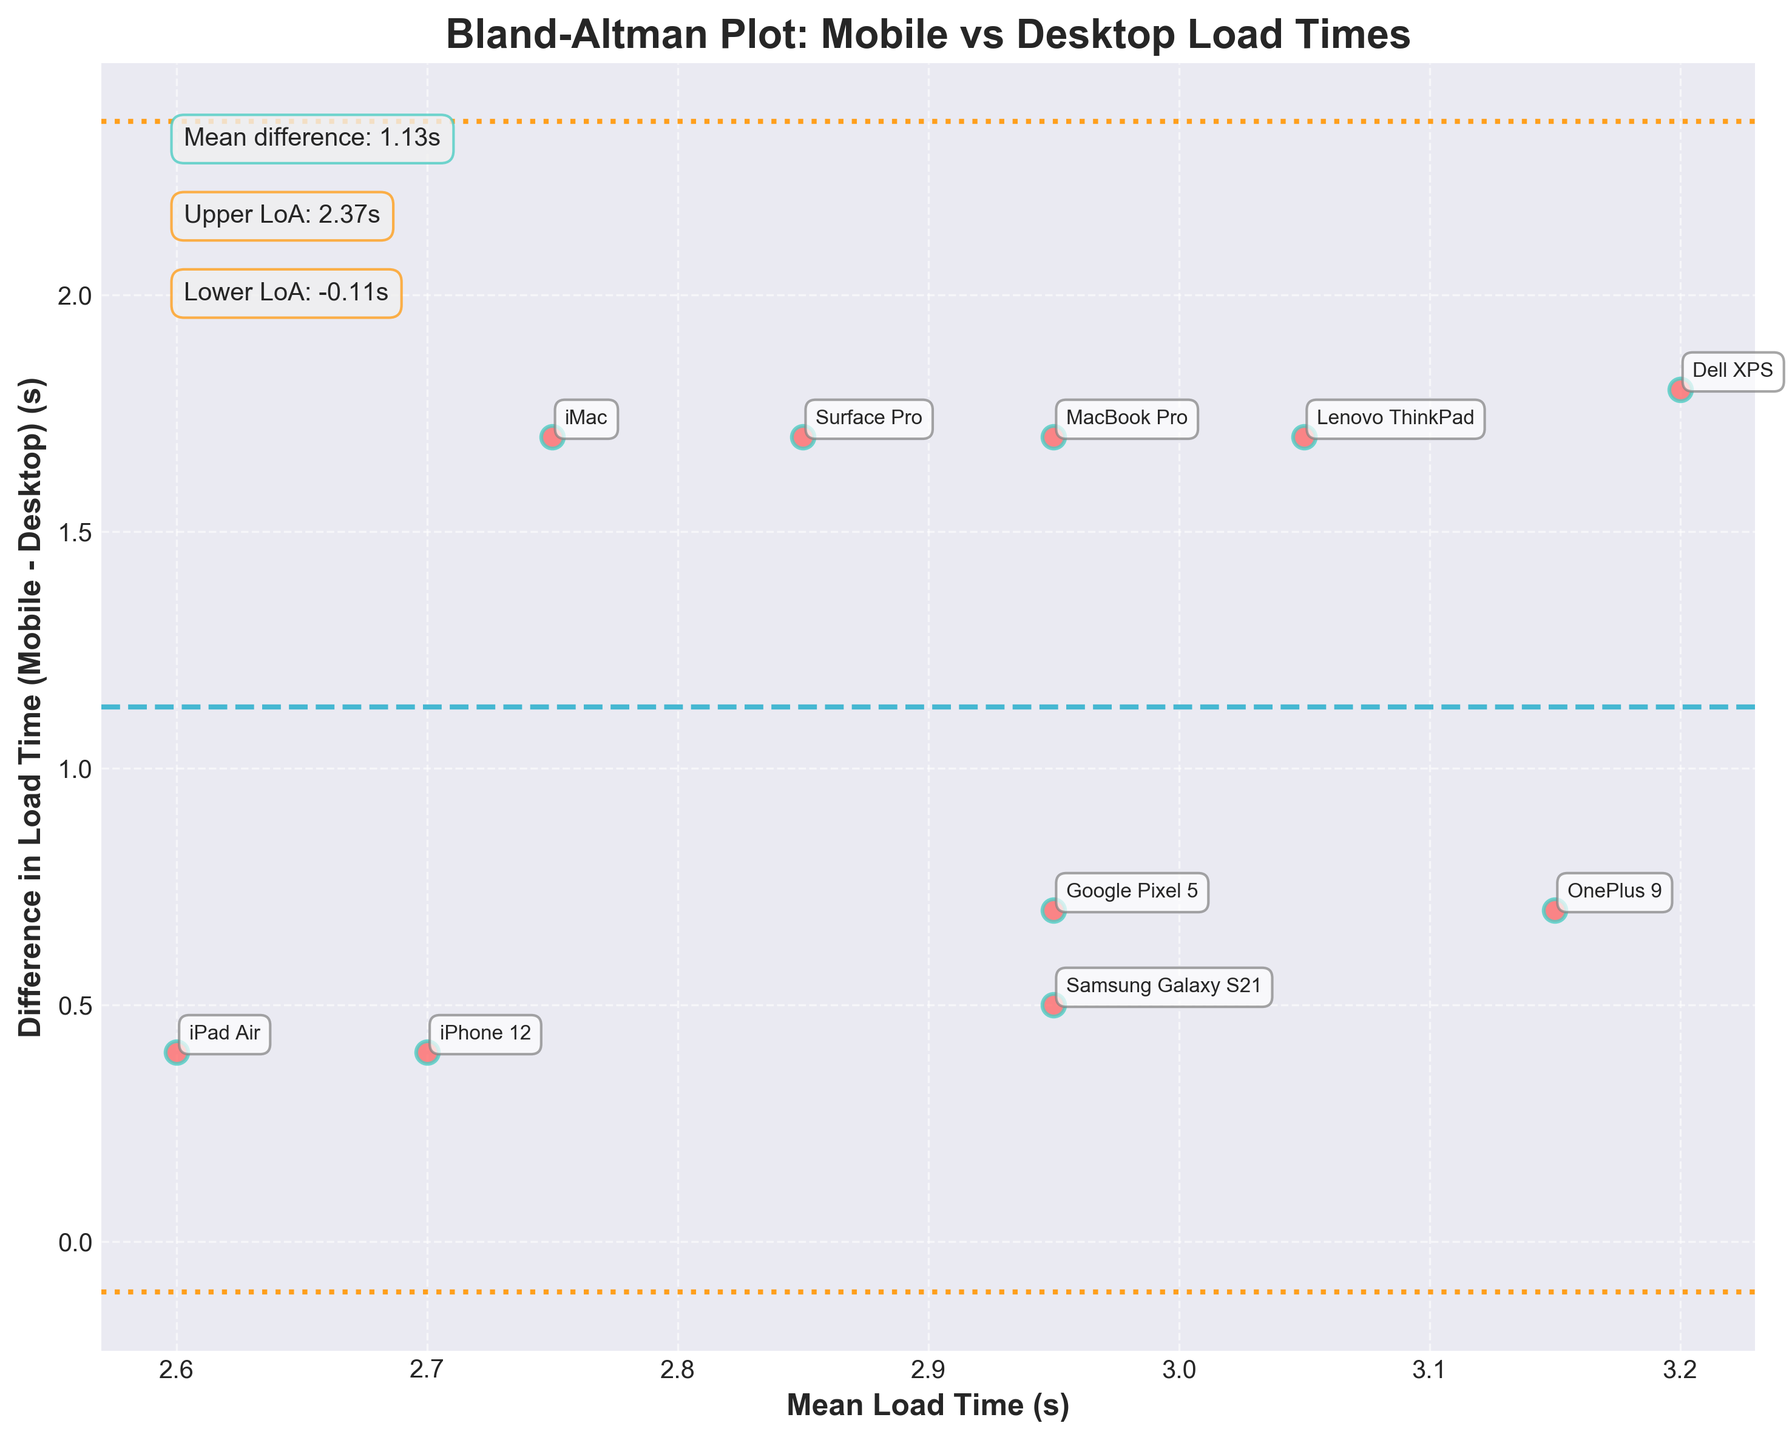What is the title of the figure? The title is mentioned at the top of the plot. It provides an overview of the data being presented.
Answer: Bland-Altman Plot: Mobile vs Desktop Load Times How many devices were analyzed in the plot? Count the number of data points (scatter points) in the plot to determine the number of devices. Each point represents a device.
Answer: 10 What is the mean difference in load times between mobile and desktop? The mean difference is indicated by the horizontal dashed line and is also annotated on the figure.
Answer: 1.41s What are the upper and lower limits of agreement? The upper and lower limits of agreement are shown as dotted lines and are annotated on the plot.
Answer: 2.17s (upper), 0.65s (lower) Which device has the highest difference in load times? Identify the data point with the largest vertical distance from the mean difference line. Check the annotations for device names.
Answer: Dell XPS Which device has the smallest average load time? Find the data point with the smallest value on the x-axis (mean load time) and identify the corresponding device from the annotations.
Answer: Surface Pro What is the difference in load times for the Samsung Galaxy S21? Locate the data point corresponding to the Samsung Galaxy S21 and read its difference value on the y-axis.
Answer: 0.5s Are there any devices with a difference greater than the upper limit of agreement? Check if any data points lie above the upper limit of agreement dotted line.
Answer: No Which browser shows the most significant load time difference on mobile? Identify the data points (devices) with the largest y-values and check the browser annotations linked to those devices.
Answer: Firefox (Dell XPS) What is the average of the mean load times (x-axis)? Calculate the average of the x-coordinates of all data points.
Answer: 3.05s 